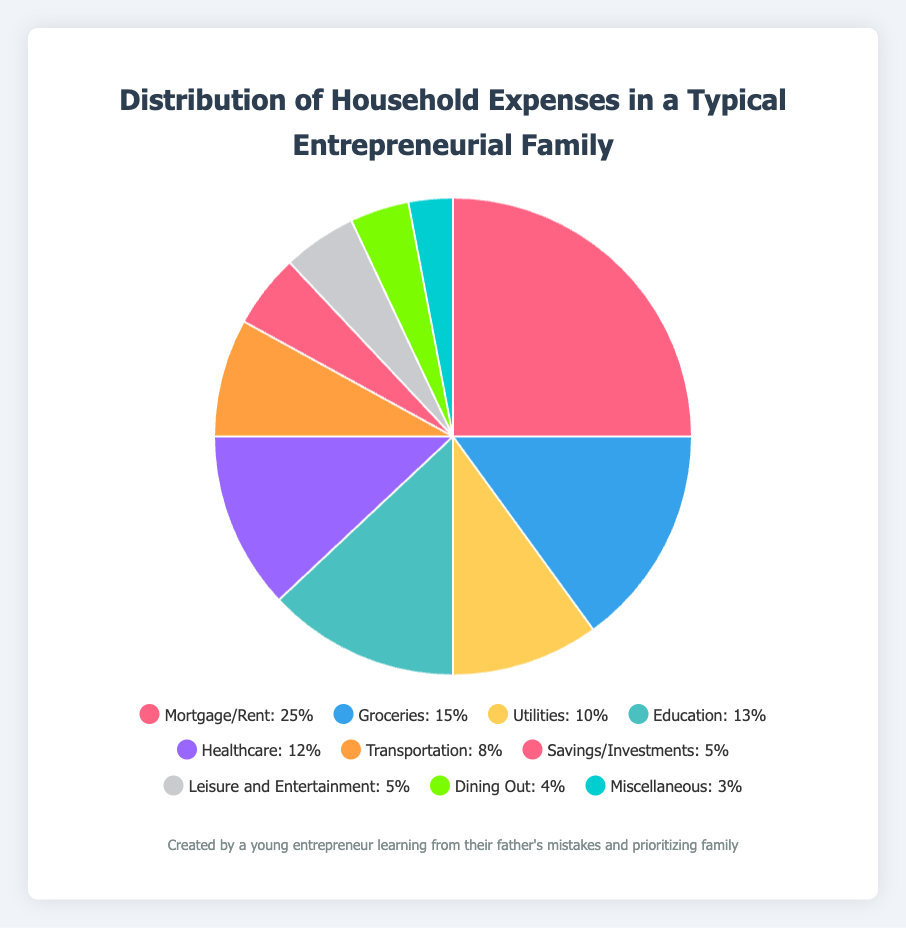What percentage of the household expenses is spent on utilities and transportation combined? To find the combined percentage of household expenses for utilities and transportation, we need to add their individual percentages: 10% (utilities) + 8% (transportation) = 18%.
Answer: 18% Which category has a higher percentage, healthcare or education? Comparing the percentages, healthcare accounts for 12% and education accounts for 13%. Education has a higher percentage.
Answer: Education What is the total percentage of the expenses attributed to savings/investments, leisure and entertainment, and dining out? Summing the percentages of savings/investments, leisure and entertainment, and dining out: 5% + 5% + 4% = 14%.
Answer: 14% Identify the category with the lowest percentage and state its value. By reviewing the slices of the pie chart, miscellaneous is the category with the lowest percentage, which is 3%.
Answer: Miscellaneous, 3% How much more is spent on mortgage/rent compared to dining out? By comparing the two categories, mortgage/rent accounts for 25% and dining out for 4%. The difference is 25% - 4% = 21%.
Answer: 21% What are the two categories with equal percentages and what is their percentage? Observing the pie chart, savings/investments and leisure and entertainment both constitute 5% of the total expenses each.
Answer: Savings/Investments and Leisure and Entertainment, 5% Which expense category occupies the largest portion of household expenses and what is its color on the chart? The largest portion of household expenses goes to mortgage/rent at 25%. Its representative color on the chart is the reddish-pink section.
Answer: Mortgage/Rent, reddish-pink If you combine the expenses for groceries and healthcare, what fraction of total household expenses would these two categories represent? Adding the percentages for groceries (15%) and healthcare (12%) results in a combined percentage of 27%. Therefore, 27% of total household expenses.
Answer: 27% Is the expenditure on education closer to the percentage spent on groceries or utilities? Comparing the values, education accounts for 13%, groceries for 15%, and utilities for 10%. The expenditure on education is closer to the percentage spent on groceries.
Answer: Groceries 